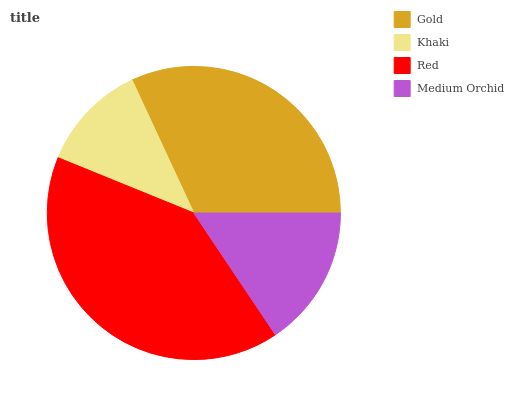Is Khaki the minimum?
Answer yes or no. Yes. Is Red the maximum?
Answer yes or no. Yes. Is Red the minimum?
Answer yes or no. No. Is Khaki the maximum?
Answer yes or no. No. Is Red greater than Khaki?
Answer yes or no. Yes. Is Khaki less than Red?
Answer yes or no. Yes. Is Khaki greater than Red?
Answer yes or no. No. Is Red less than Khaki?
Answer yes or no. No. Is Gold the high median?
Answer yes or no. Yes. Is Medium Orchid the low median?
Answer yes or no. Yes. Is Khaki the high median?
Answer yes or no. No. Is Red the low median?
Answer yes or no. No. 